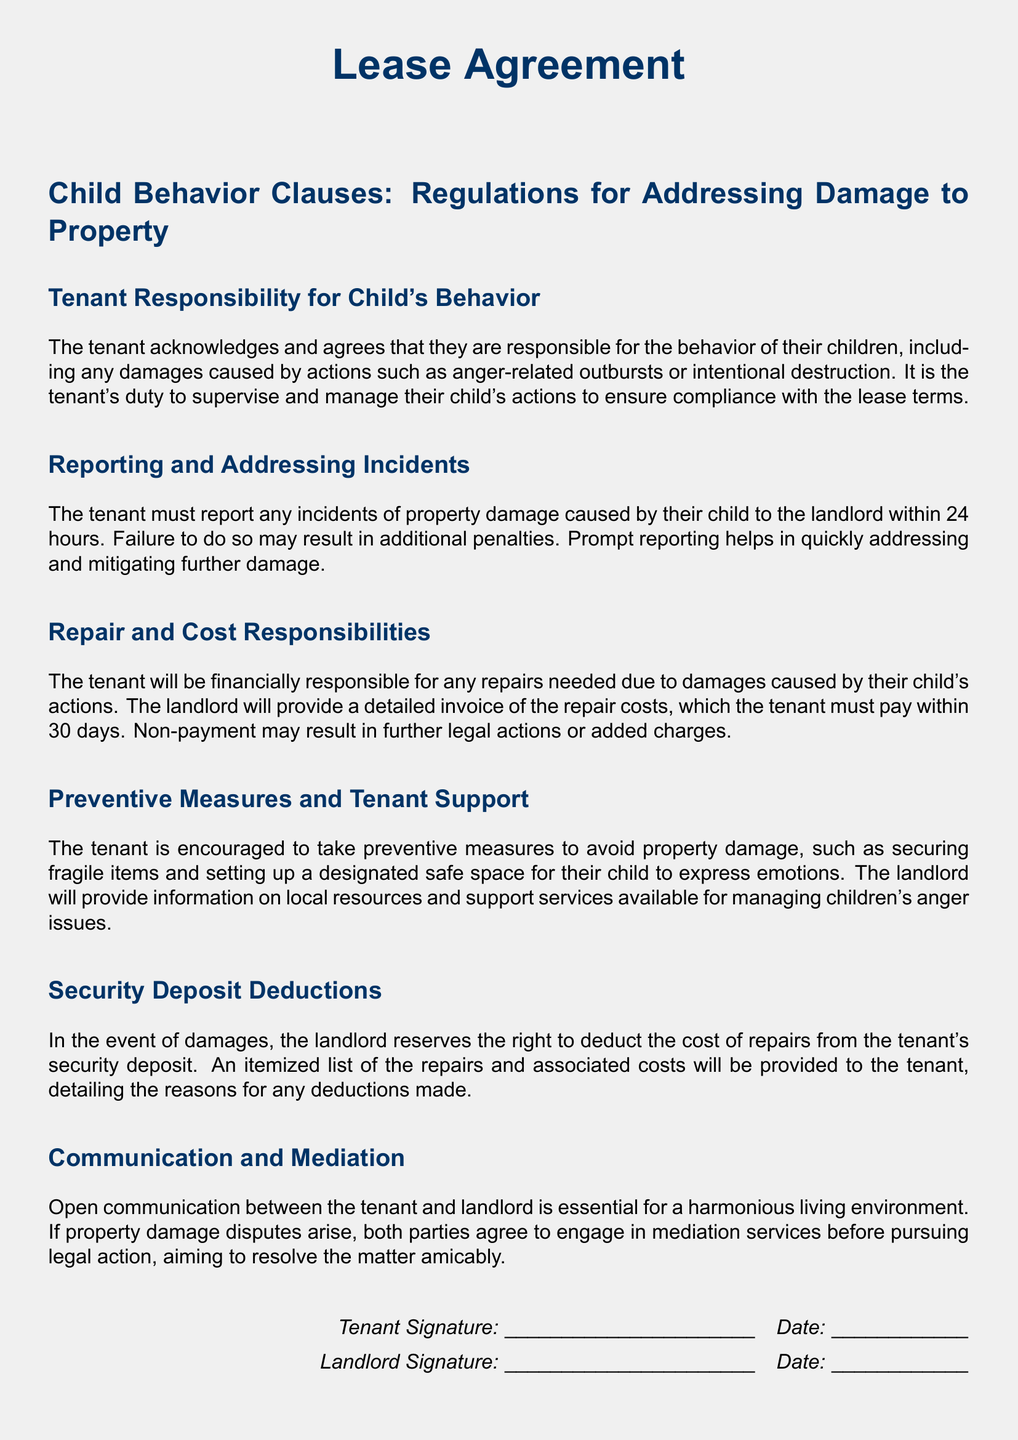What is the title of the document? The title of the document is prominently displayed at the top, stating that it is a Lease Agreement.
Answer: Lease Agreement What is the tenant responsible for regarding their child's behavior? The document specifies that the tenant is responsible for the behavior of their children, including any damages caused.
Answer: Behavior of their children What is the time frame in which the tenant must report property damage? The document indicates that the tenant must report damage within a specific time limit, which is stated clearly.
Answer: 24 hours Who provides the invoice for repair costs? The document states that the landlord will provide a detailed invoice of the repair costs incurred due to a child's actions.
Answer: Landlord How long does the tenant have to pay for repairs? The document clearly specifies the time frame for payment related to repairs, providing a straightforward duration.
Answer: 30 days What can the landlord deduct from the security deposit? The document mentions that the landlord reserves the right to deduct certain costs from a specific financial amount provided by the tenant.
Answer: Repair costs What should both parties engage in before pursuing legal action? The document emphasizes the importance of resolving disputes through a specific process before escalating the situation legally.
Answer: Mediation services What is one preventive measure the tenant is encouraged to take? The document suggests a specific measure the tenant can adopt to minimize damage to the property, related to the child's actions.
Answer: Securing fragile items What type of support will the landlord provide to the tenant? The document mentions that the landlord will provide information on certain resources available to assist the tenant in managing specific issues.
Answer: Local resources and support services 